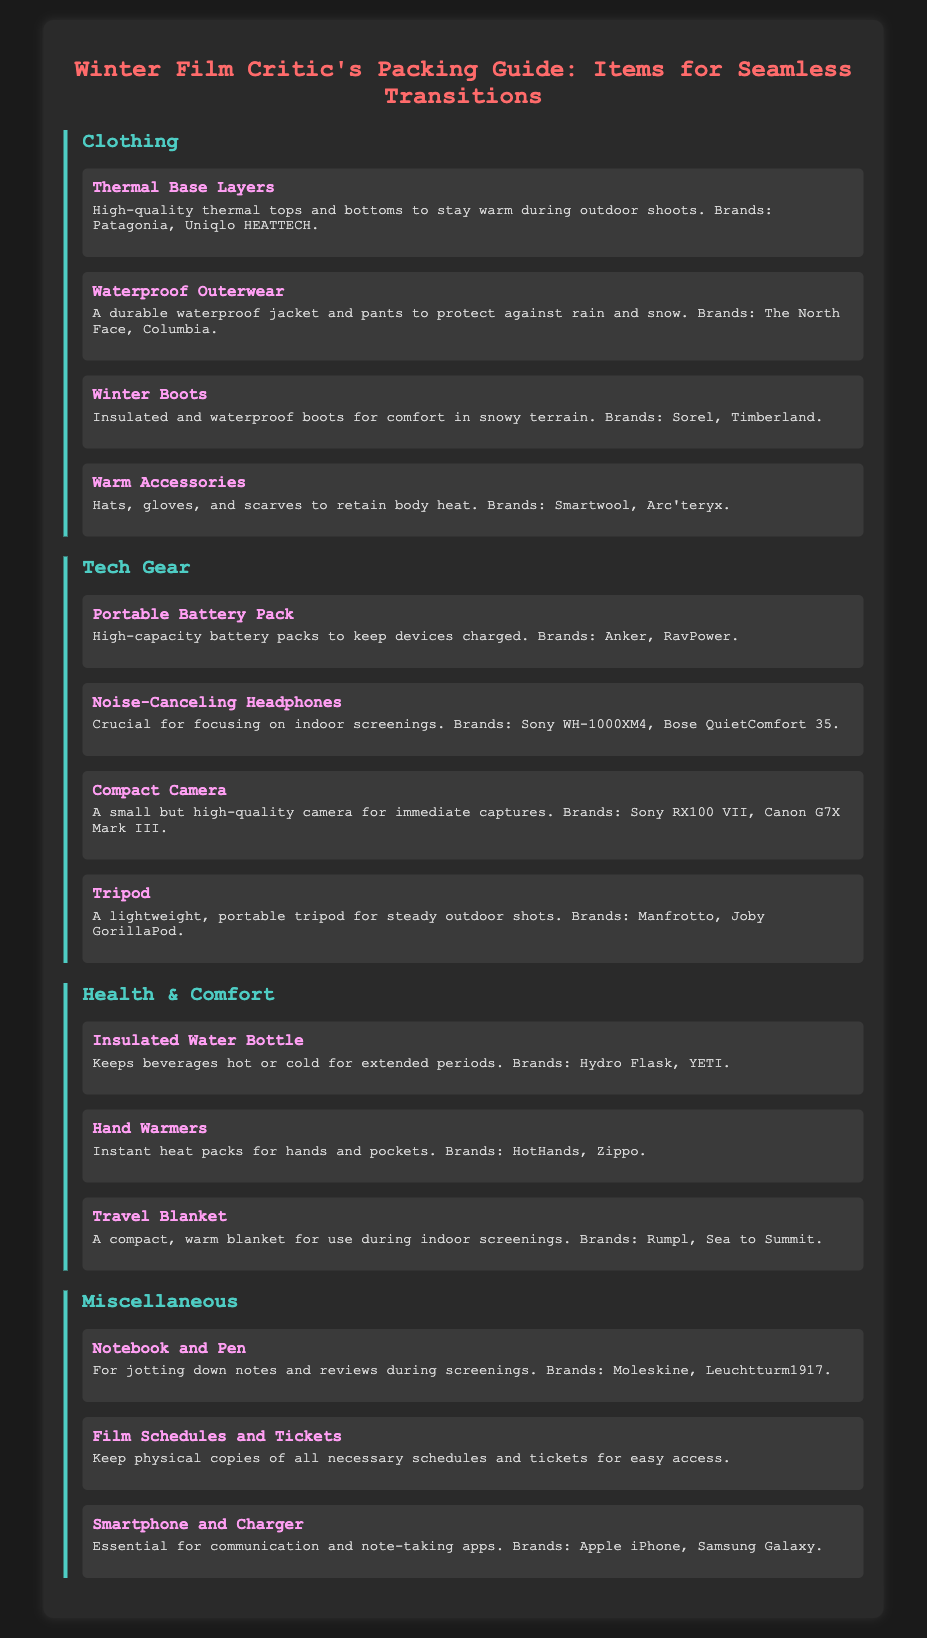What are examples of high-quality thermal base layers? The document lists brands like Patagonia and Uniqlo HEATTECH as examples of high-quality thermal base layers.
Answer: Patagonia, Uniqlo HEATTECH What type of headphones are recommended for indoor screenings? The document specifies noise-canceling headphones as crucial for focusing on indoor screenings.
Answer: Noise-Canceling Headphones Which brand is mentioned for insulated water bottles? Hydro Flask is one of the brands listed for insulated water bottles.
Answer: Hydro Flask How many clothing items are listed? There are four clothing items listed under the Clothing category in the document.
Answer: Four What are hand warmers used for? Hand warmers are described as instant heat packs for hands and pockets.
Answer: Instant heat packs What is the purpose of a portable battery pack? The document states that portable battery packs are for keeping devices charged.
Answer: Keeping devices charged How many categories of items are there in the guide? The guide contains four distinct categories of items listed.
Answer: Four Which brand is suggested for portable tripods? The document suggests Manfrotto as a brand for lightweight, portable tripods.
Answer: Manfrotto What item is recommended for jotting down notes during screenings? A notebook and pen are recommended for jotting down notes and reviews during screenings.
Answer: Notebook and Pen 